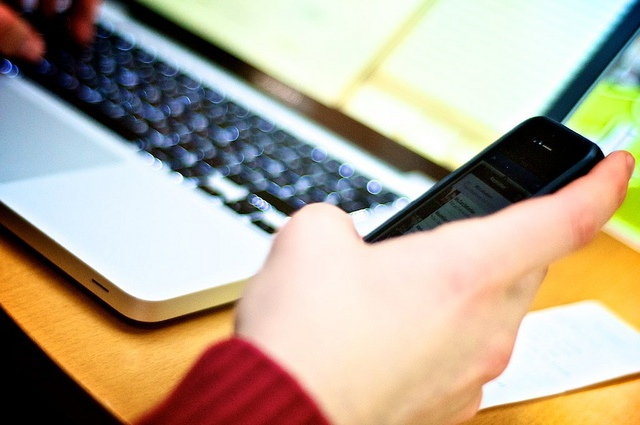Describe the objects in this image and their specific colors. I can see laptop in maroon, ivory, black, lightblue, and blue tones, keyboard in maroon, white, black, lightblue, and blue tones, people in maroon, white, tan, and brown tones, and cell phone in maroon, black, purple, darkblue, and gray tones in this image. 